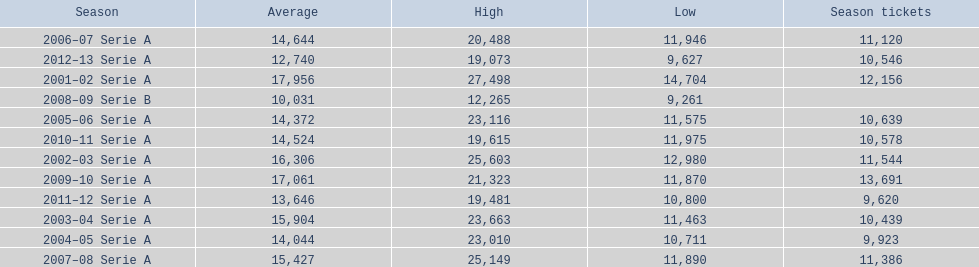What seasons were played at the stadio ennio tardini 2001–02 Serie A, 2002–03 Serie A, 2003–04 Serie A, 2004–05 Serie A, 2005–06 Serie A, 2006–07 Serie A, 2007–08 Serie A, 2008–09 Serie B, 2009–10 Serie A, 2010–11 Serie A, 2011–12 Serie A, 2012–13 Serie A. Which of these seasons had season tickets? 2001–02 Serie A, 2002–03 Serie A, 2003–04 Serie A, 2004–05 Serie A, 2005–06 Serie A, 2006–07 Serie A, 2007–08 Serie A, 2009–10 Serie A, 2010–11 Serie A, 2011–12 Serie A, 2012–13 Serie A. How many season tickets did the 2007-08 season have? 11,386. 